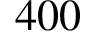Convert formula to latex. <formula><loc_0><loc_0><loc_500><loc_500>4 0 0</formula> 